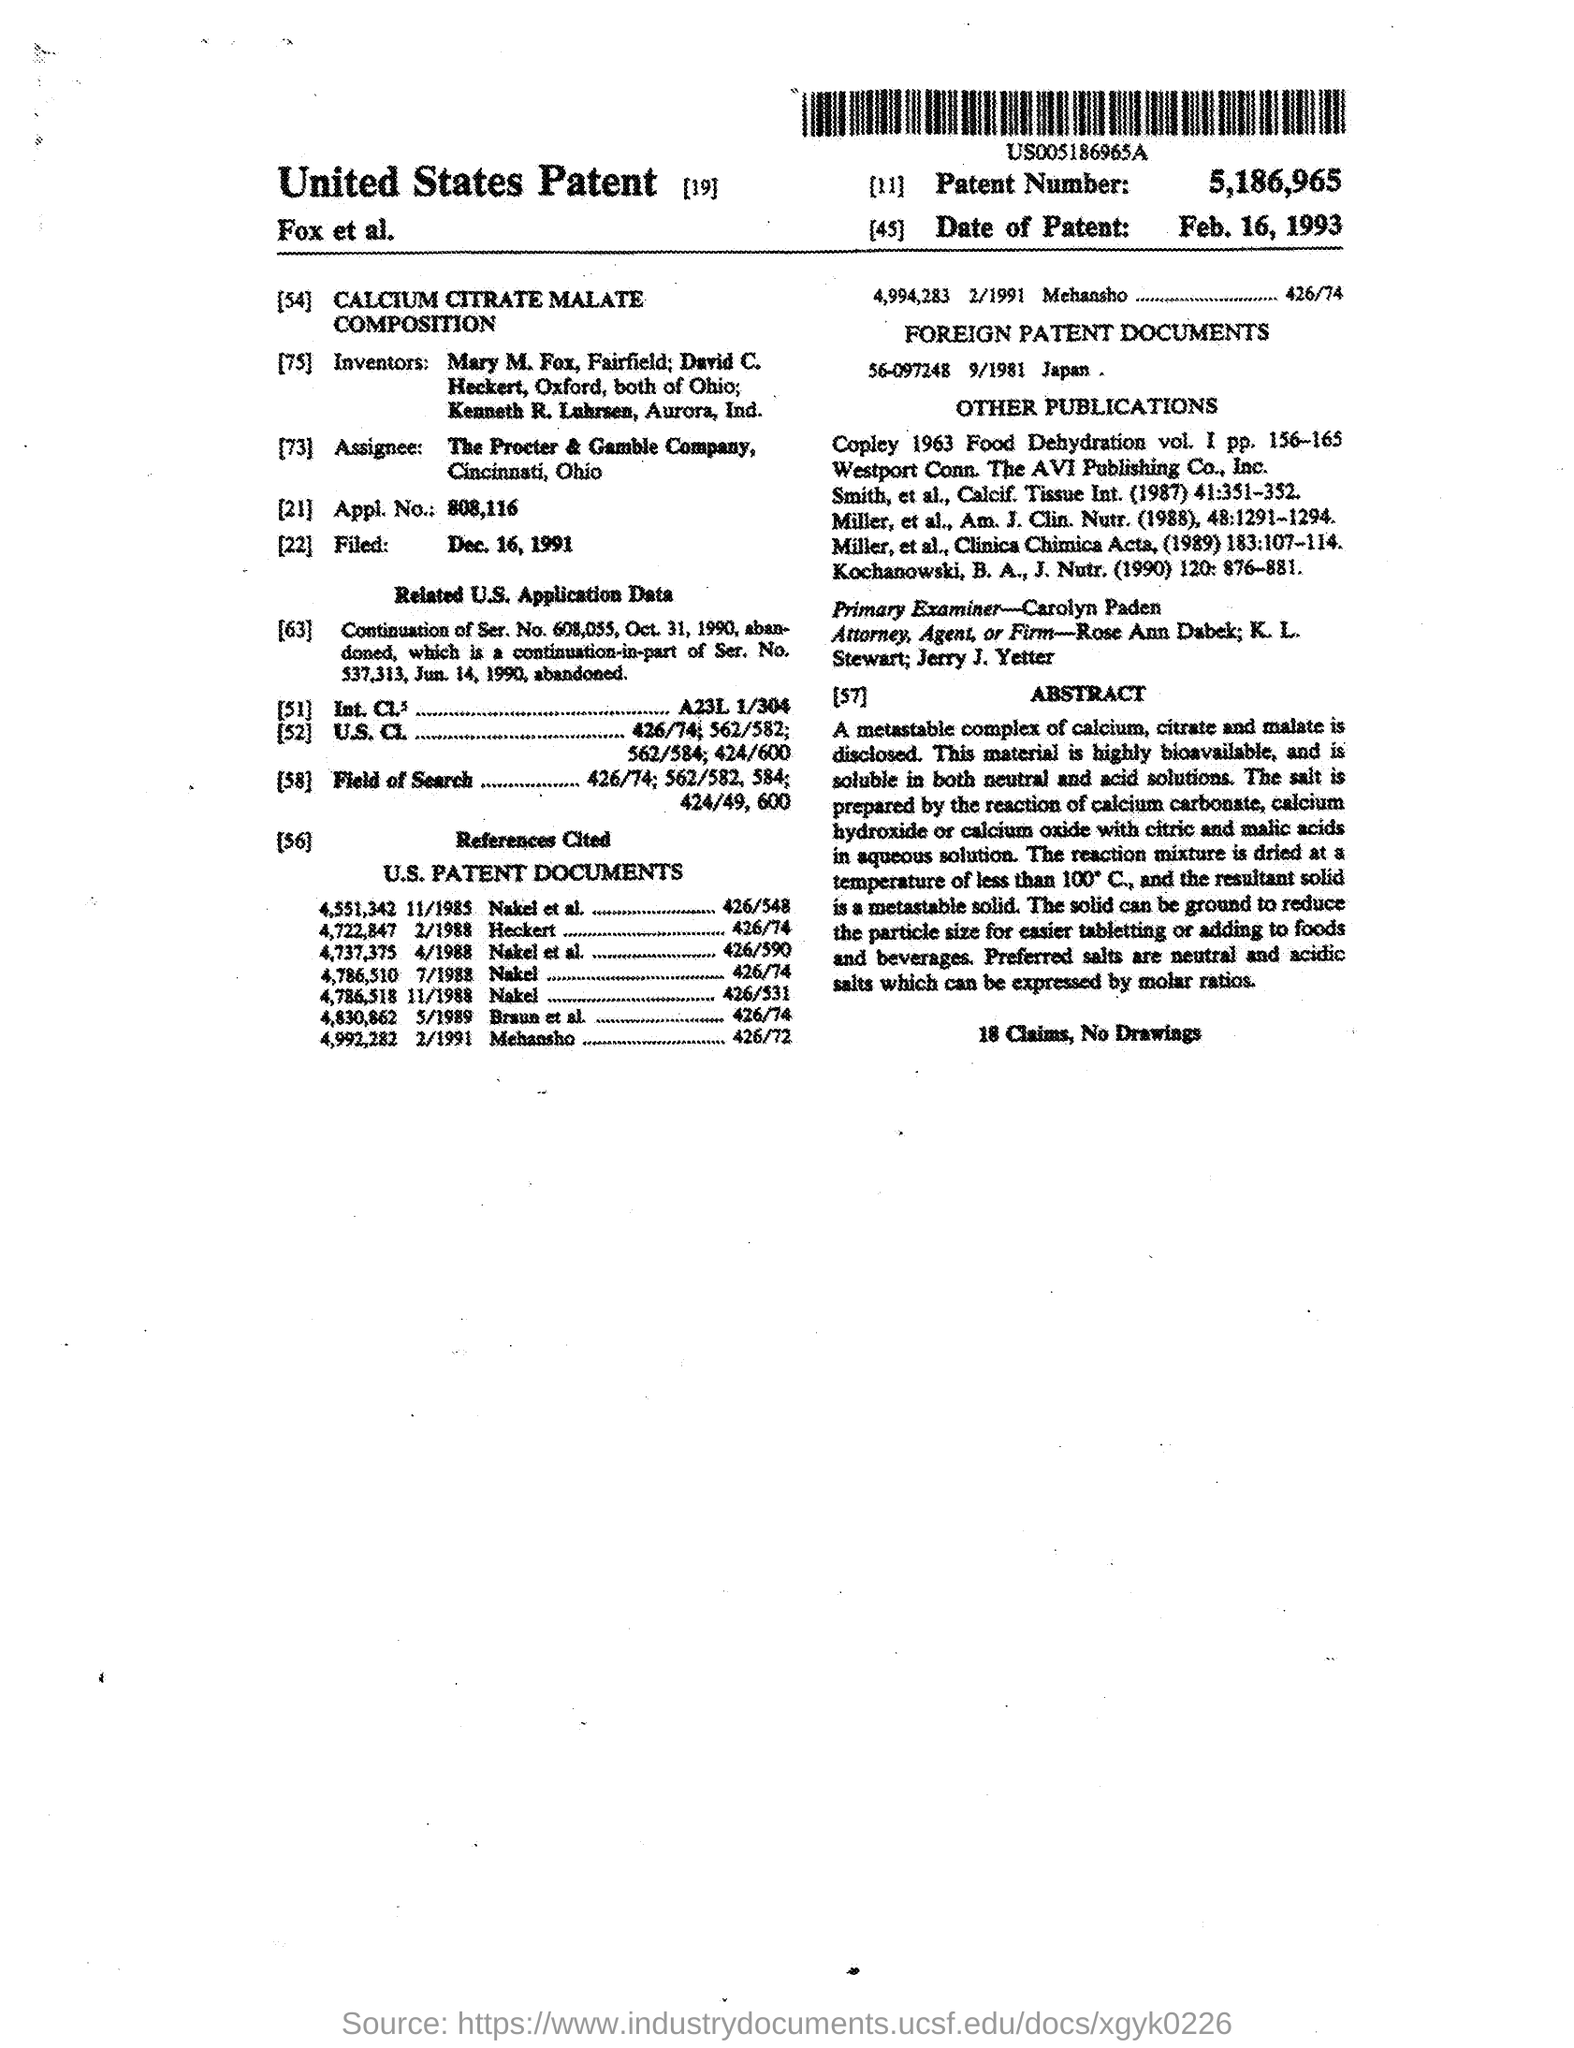Whats the Patent Number?
Offer a very short reply. 5,186,965. What's the FOREIGN PATENT DOCUMENT?
Give a very brief answer. 56-097248 9/1981 JAPAN. Who was the Primary Examiner?
Provide a succinct answer. CAROLYN PADEN. What is  the solubility of this salt?
Your response must be concise. SOLUBLE IN BOTH NEUTRAL AND ACID SOLUTIONS. Why  the Praticle sizes is reduced?
Keep it short and to the point. For easier Tabletting or adding to foods and beverages. 